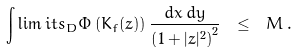Convert formula to latex. <formula><loc_0><loc_0><loc_500><loc_500>\int \lim i t s _ { D } \Phi \left ( K _ { f } ( z ) \right ) \frac { d x \, d y } { \left ( 1 + | z | ^ { 2 } \right ) ^ { 2 } } \ \leq \ M \, .</formula> 